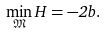Convert formula to latex. <formula><loc_0><loc_0><loc_500><loc_500>\min _ { \mathfrak { M } } H = - 2 b .</formula> 